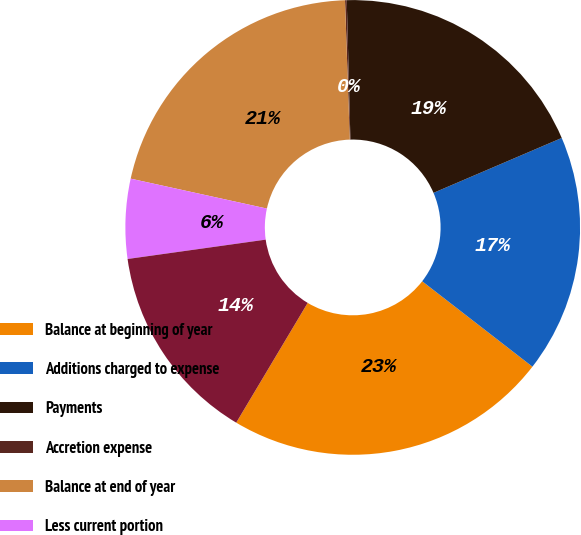Convert chart to OTSL. <chart><loc_0><loc_0><loc_500><loc_500><pie_chart><fcel>Balance at beginning of year<fcel>Additions charged to expense<fcel>Payments<fcel>Accretion expense<fcel>Balance at end of year<fcel>Less current portion<fcel>Long-term portion<nl><fcel>23.07%<fcel>16.93%<fcel>18.98%<fcel>0.12%<fcel>21.02%<fcel>5.66%<fcel>14.22%<nl></chart> 